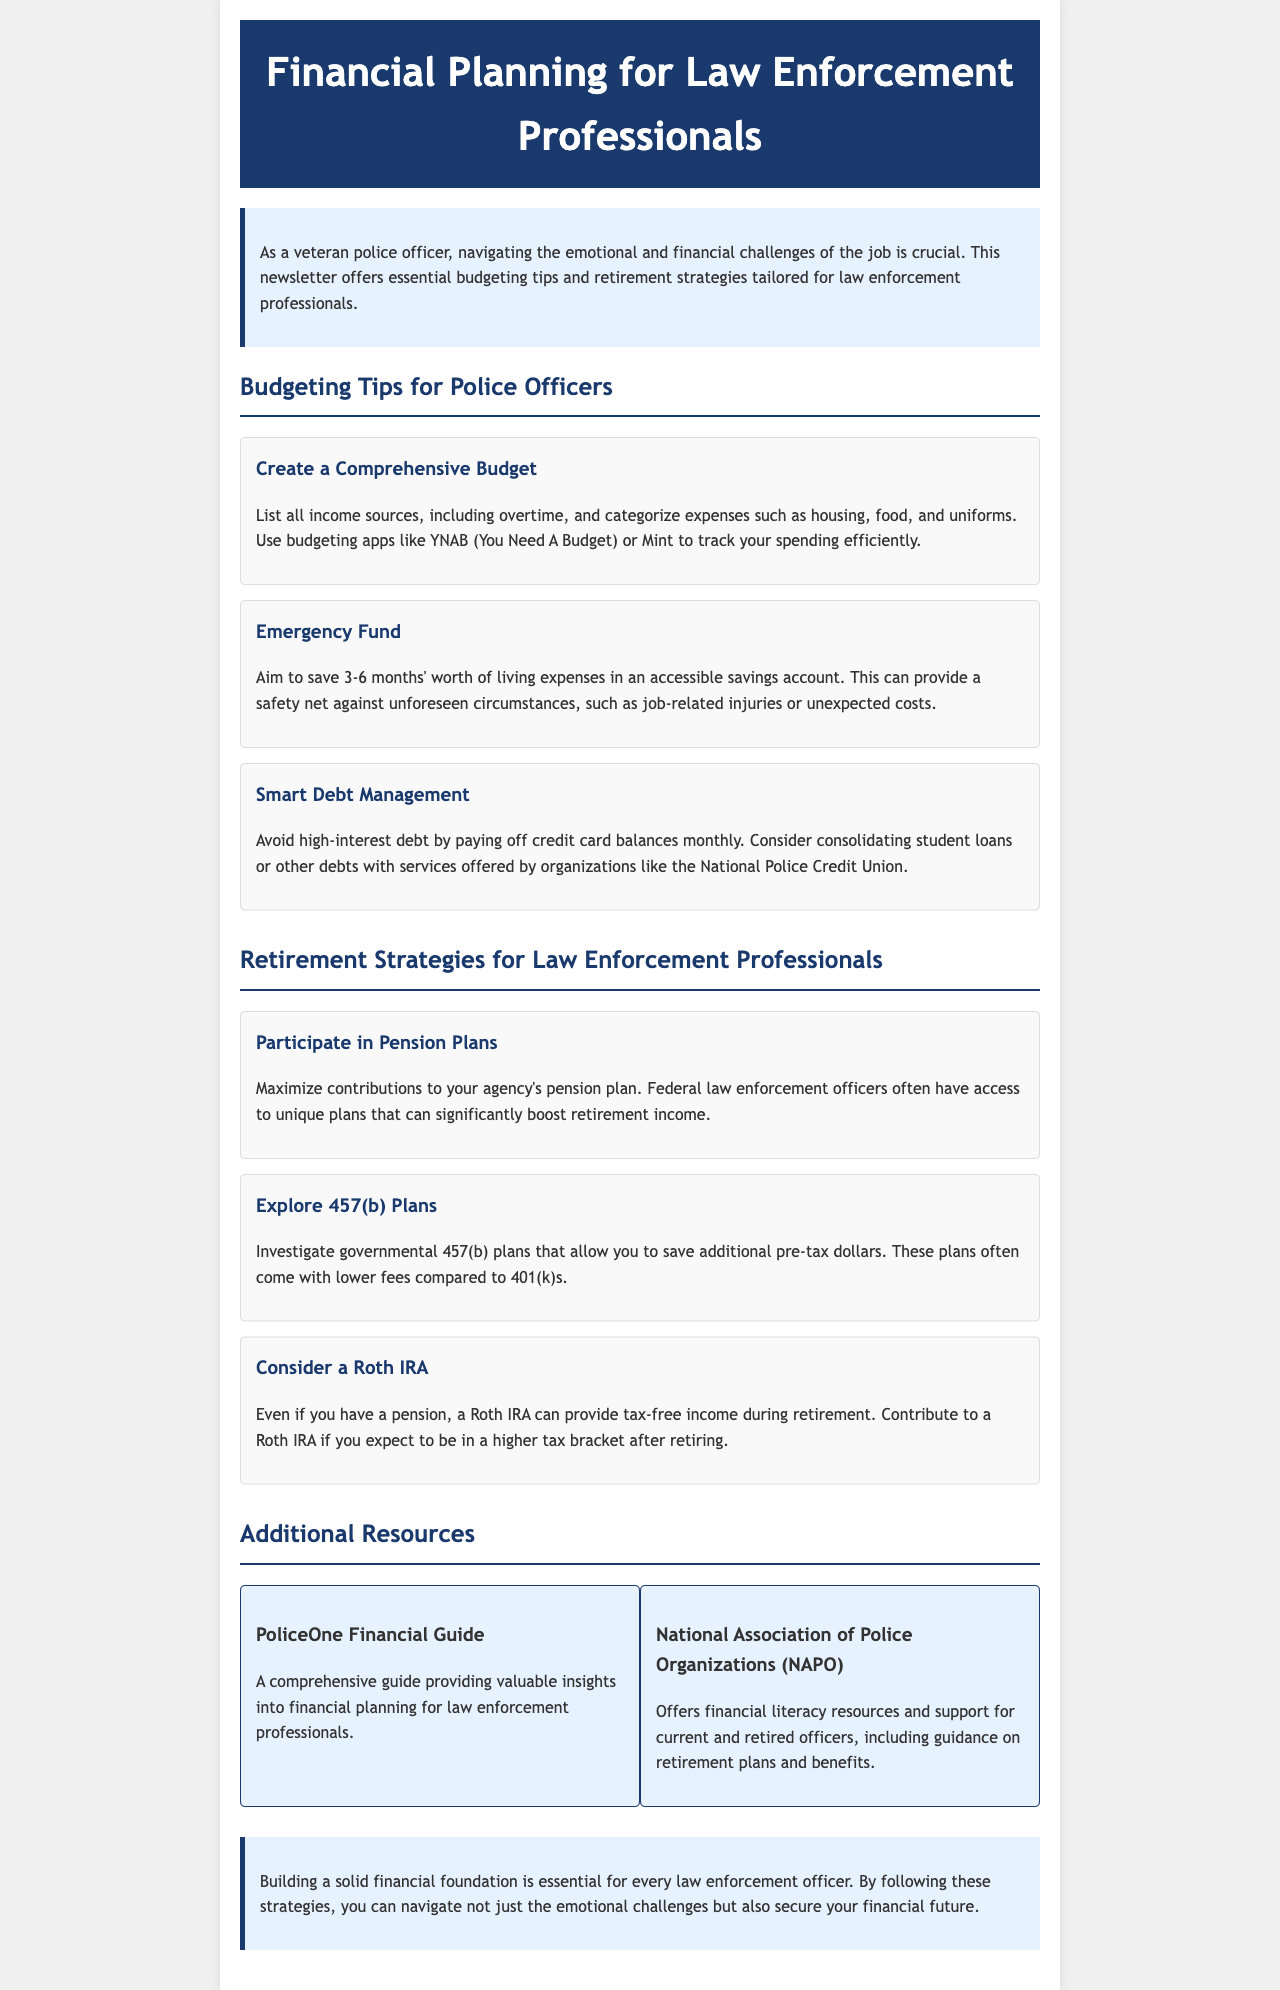What is the title of the newsletter? The title of the newsletter is provided in the header of the document.
Answer: Financial Planning for Law Enforcement Professionals How many months' worth of expenses should you save for an emergency fund? The document states the recommended amount to save for an emergency fund based on best practices.
Answer: 3-6 months Which budgeting app is mentioned in the document? The newsletter lists specific budgeting applications that law enforcement professionals can use, highlighting one example.
Answer: YNAB (You Need A Budget) What type of account can provide tax-free income during retirement? The document suggests a specific retirement account that offers tax-free income, assisting officers in financial planning.
Answer: Roth IRA What organization offers support for current and retired officers? The newsletter references an organization that provides financial literacy resources relevant to law enforcement professionals.
Answer: National Association of Police Organizations (NAPO) Which retirement plan should officers maximize contributions to? The document emphasizes the importance of contributing to a specific type of retirement plan available to officers.
Answer: pension plan How many resource items are listed in the resources section? The newsletter includes a section dedicated to additional resources, detailing how many distinct resources are provided.
Answer: 2 What is one of the main topics covered in the newsletter? The newsletter covers specific aspects of financial planning, highlighting multiple key themes.
Answer: Budgeting Tips What color is used for the section headers? The document describes the stylistic choices made for section headers, which indicate their visual importance.
Answer: Blue 